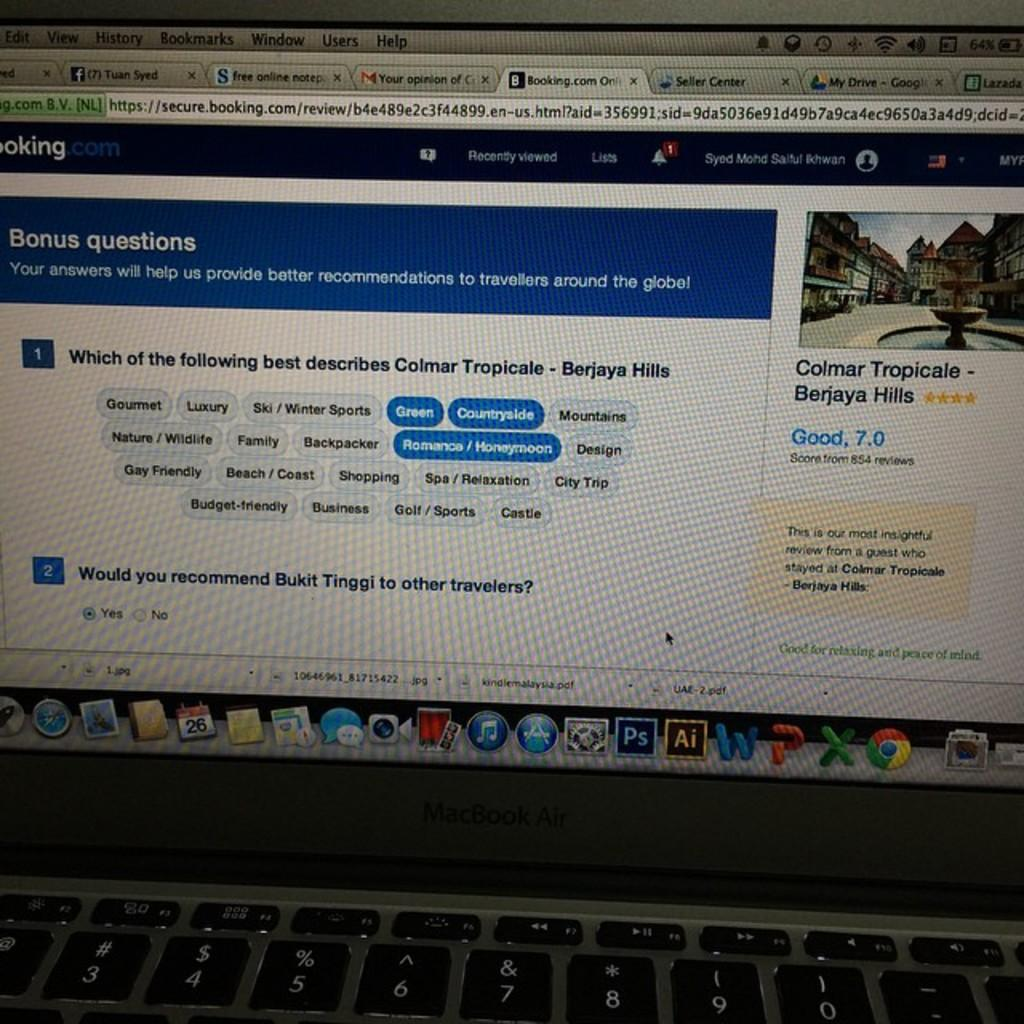<image>
Create a compact narrative representing the image presented. A laptop shows that the user recommends Bukit Tinggi to other travelers. 